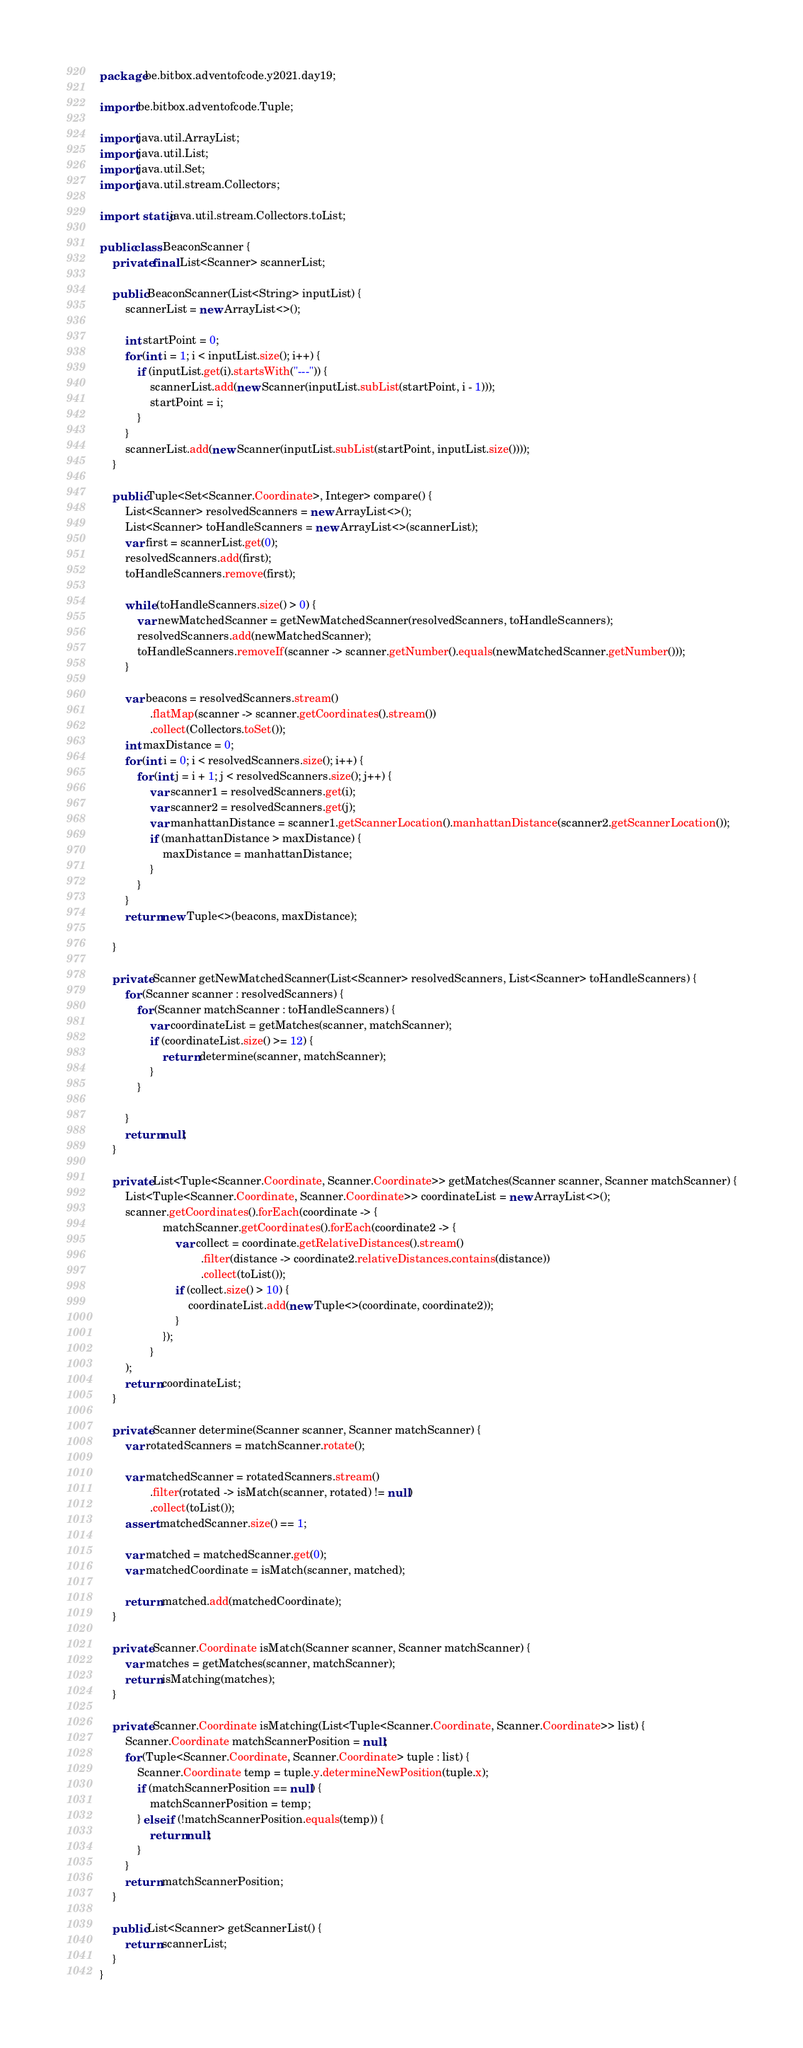Convert code to text. <code><loc_0><loc_0><loc_500><loc_500><_Java_>package be.bitbox.adventofcode.y2021.day19;

import be.bitbox.adventofcode.Tuple;

import java.util.ArrayList;
import java.util.List;
import java.util.Set;
import java.util.stream.Collectors;

import static java.util.stream.Collectors.toList;

public class BeaconScanner {
    private final List<Scanner> scannerList;

    public BeaconScanner(List<String> inputList) {
        scannerList = new ArrayList<>();

        int startPoint = 0;
        for (int i = 1; i < inputList.size(); i++) {
            if (inputList.get(i).startsWith("---")) {
                scannerList.add(new Scanner(inputList.subList(startPoint, i - 1)));
                startPoint = i;
            }
        }
        scannerList.add(new Scanner(inputList.subList(startPoint, inputList.size())));
    }

    public Tuple<Set<Scanner.Coordinate>, Integer> compare() {
        List<Scanner> resolvedScanners = new ArrayList<>();
        List<Scanner> toHandleScanners = new ArrayList<>(scannerList);
        var first = scannerList.get(0);
        resolvedScanners.add(first);
        toHandleScanners.remove(first);

        while (toHandleScanners.size() > 0) {
            var newMatchedScanner = getNewMatchedScanner(resolvedScanners, toHandleScanners);
            resolvedScanners.add(newMatchedScanner);
            toHandleScanners.removeIf(scanner -> scanner.getNumber().equals(newMatchedScanner.getNumber()));
        }

        var beacons = resolvedScanners.stream()
                .flatMap(scanner -> scanner.getCoordinates().stream())
                .collect(Collectors.toSet());
        int maxDistance = 0;
        for (int i = 0; i < resolvedScanners.size(); i++) {
            for (int j = i + 1; j < resolvedScanners.size(); j++) {
                var scanner1 = resolvedScanners.get(i);
                var scanner2 = resolvedScanners.get(j);
                var manhattanDistance = scanner1.getScannerLocation().manhattanDistance(scanner2.getScannerLocation());
                if (manhattanDistance > maxDistance) {
                    maxDistance = manhattanDistance;
                }
            }
        }
        return new Tuple<>(beacons, maxDistance);

    }

    private Scanner getNewMatchedScanner(List<Scanner> resolvedScanners, List<Scanner> toHandleScanners) {
        for (Scanner scanner : resolvedScanners) {
            for (Scanner matchScanner : toHandleScanners) {
                var coordinateList = getMatches(scanner, matchScanner);
                if (coordinateList.size() >= 12) {
                    return determine(scanner, matchScanner);
                }
            }

        }
        return null;
    }

    private List<Tuple<Scanner.Coordinate, Scanner.Coordinate>> getMatches(Scanner scanner, Scanner matchScanner) {
        List<Tuple<Scanner.Coordinate, Scanner.Coordinate>> coordinateList = new ArrayList<>();
        scanner.getCoordinates().forEach(coordinate -> {
                    matchScanner.getCoordinates().forEach(coordinate2 -> {
                        var collect = coordinate.getRelativeDistances().stream()
                                .filter(distance -> coordinate2.relativeDistances.contains(distance))
                                .collect(toList());
                        if (collect.size() > 10) {
                            coordinateList.add(new Tuple<>(coordinate, coordinate2));
                        }
                    });
                }
        );
        return coordinateList;
    }

    private Scanner determine(Scanner scanner, Scanner matchScanner) {
        var rotatedScanners = matchScanner.rotate();

        var matchedScanner = rotatedScanners.stream()
                .filter(rotated -> isMatch(scanner, rotated) != null)
                .collect(toList());
        assert matchedScanner.size() == 1;

        var matched = matchedScanner.get(0);
        var matchedCoordinate = isMatch(scanner, matched);

        return matched.add(matchedCoordinate);
    }

    private Scanner.Coordinate isMatch(Scanner scanner, Scanner matchScanner) {
        var matches = getMatches(scanner, matchScanner);
        return isMatching(matches);
    }

    private Scanner.Coordinate isMatching(List<Tuple<Scanner.Coordinate, Scanner.Coordinate>> list) {
        Scanner.Coordinate matchScannerPosition = null;
        for (Tuple<Scanner.Coordinate, Scanner.Coordinate> tuple : list) {
            Scanner.Coordinate temp = tuple.y.determineNewPosition(tuple.x);
            if (matchScannerPosition == null) {
                matchScannerPosition = temp;
            } else if (!matchScannerPosition.equals(temp)) {
                return null;
            }
        }
        return matchScannerPosition;
    }

    public List<Scanner> getScannerList() {
        return scannerList;
    }
}
</code> 